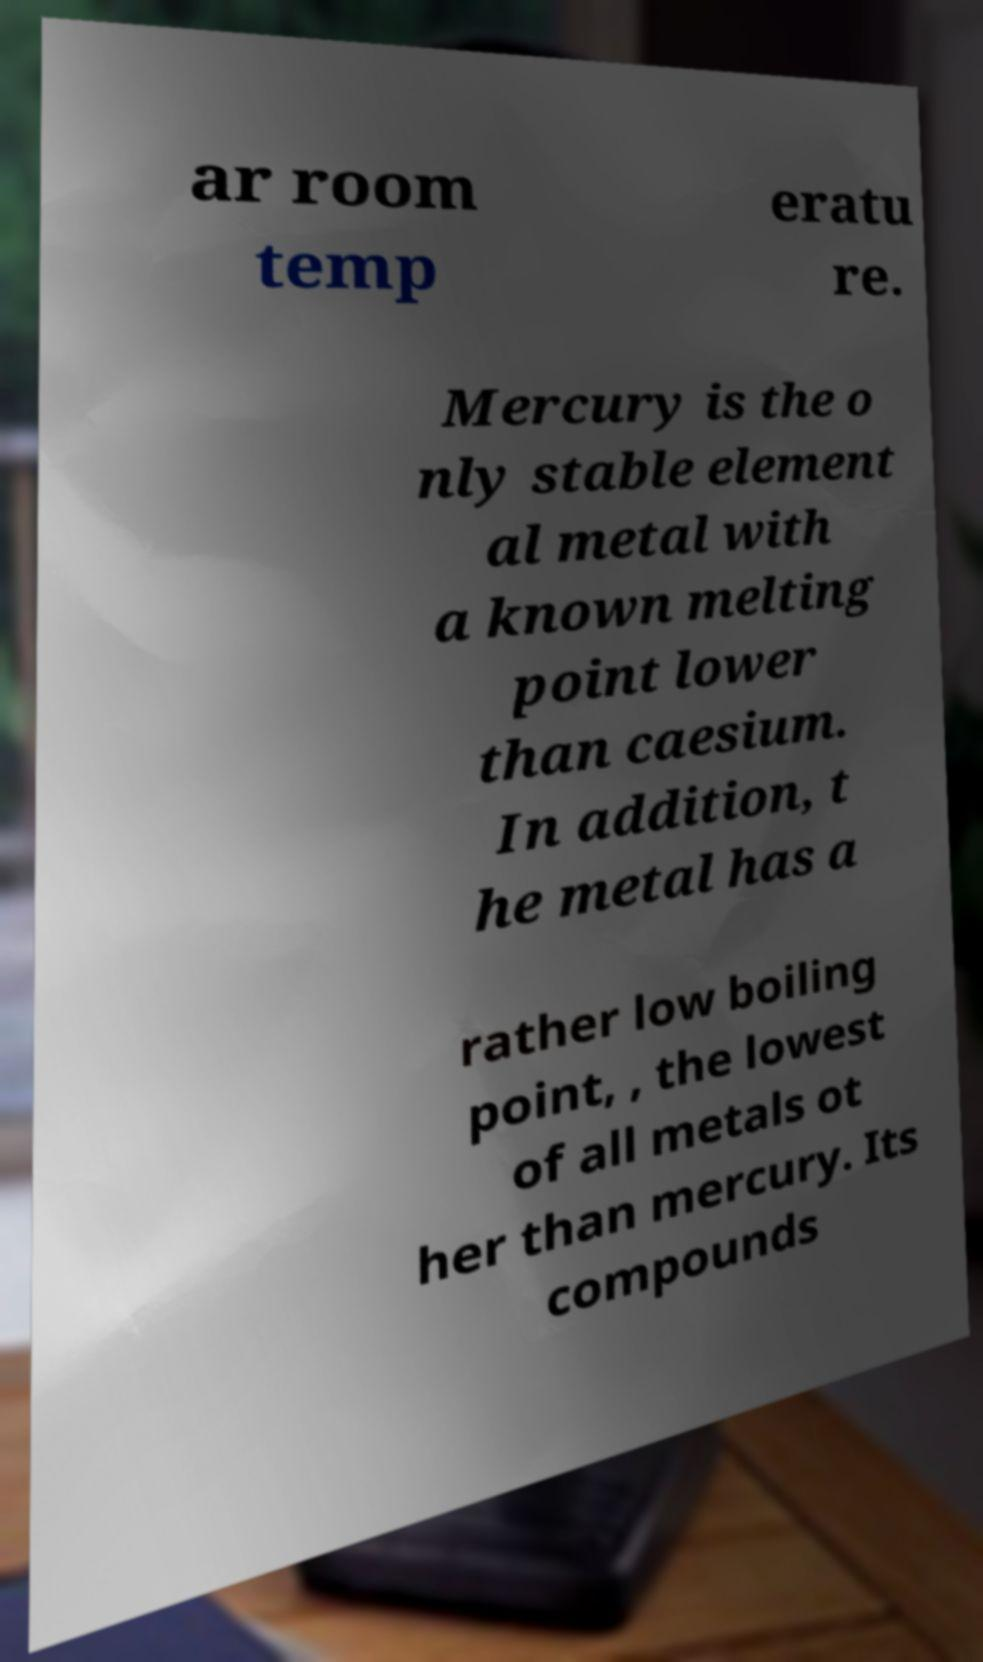I need the written content from this picture converted into text. Can you do that? ar room temp eratu re. Mercury is the o nly stable element al metal with a known melting point lower than caesium. In addition, t he metal has a rather low boiling point, , the lowest of all metals ot her than mercury. Its compounds 